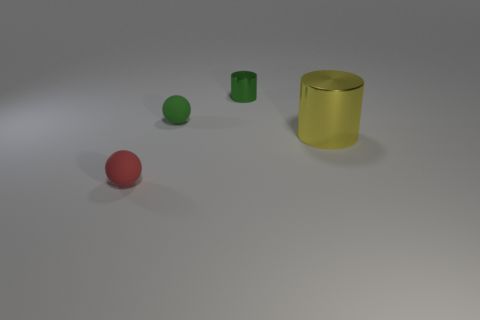Add 1 green spheres. How many objects exist? 5 Subtract all yellow cylinders. How many cylinders are left? 1 Add 3 tiny shiny objects. How many tiny shiny objects are left? 4 Add 2 balls. How many balls exist? 4 Subtract 0 cyan spheres. How many objects are left? 4 Subtract 1 spheres. How many spheres are left? 1 Subtract all purple cylinders. Subtract all green cubes. How many cylinders are left? 2 Subtract all small red matte blocks. Subtract all small rubber things. How many objects are left? 2 